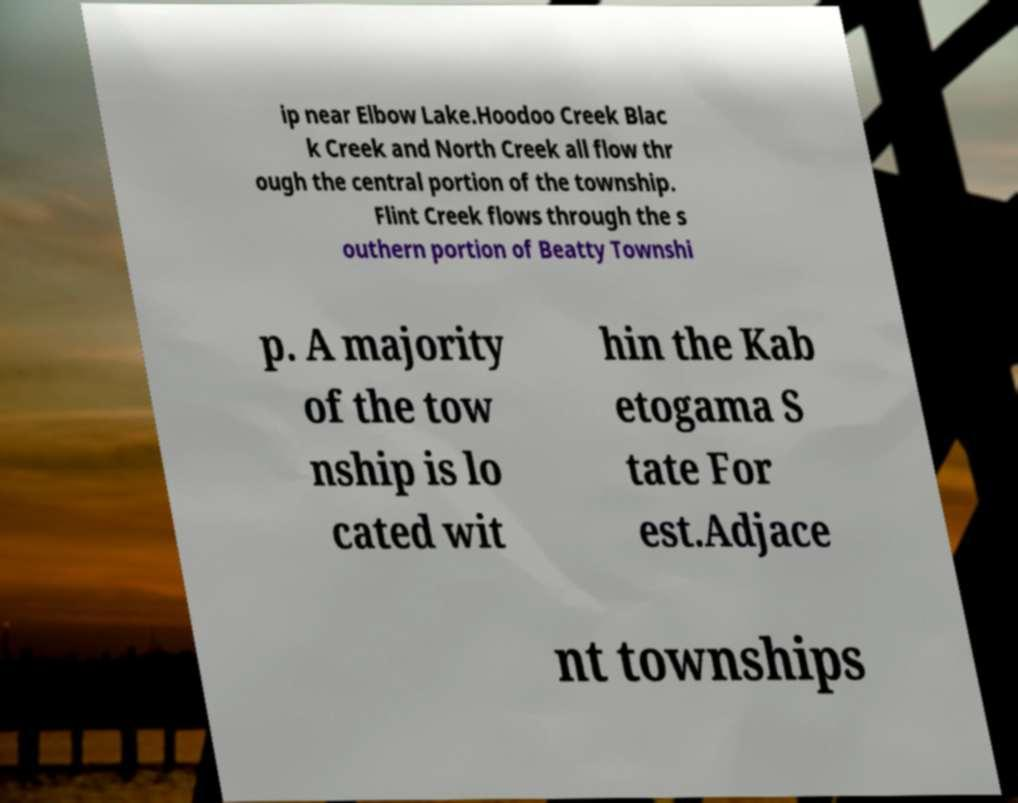Can you read and provide the text displayed in the image?This photo seems to have some interesting text. Can you extract and type it out for me? ip near Elbow Lake.Hoodoo Creek Blac k Creek and North Creek all flow thr ough the central portion of the township. Flint Creek flows through the s outhern portion of Beatty Townshi p. A majority of the tow nship is lo cated wit hin the Kab etogama S tate For est.Adjace nt townships 